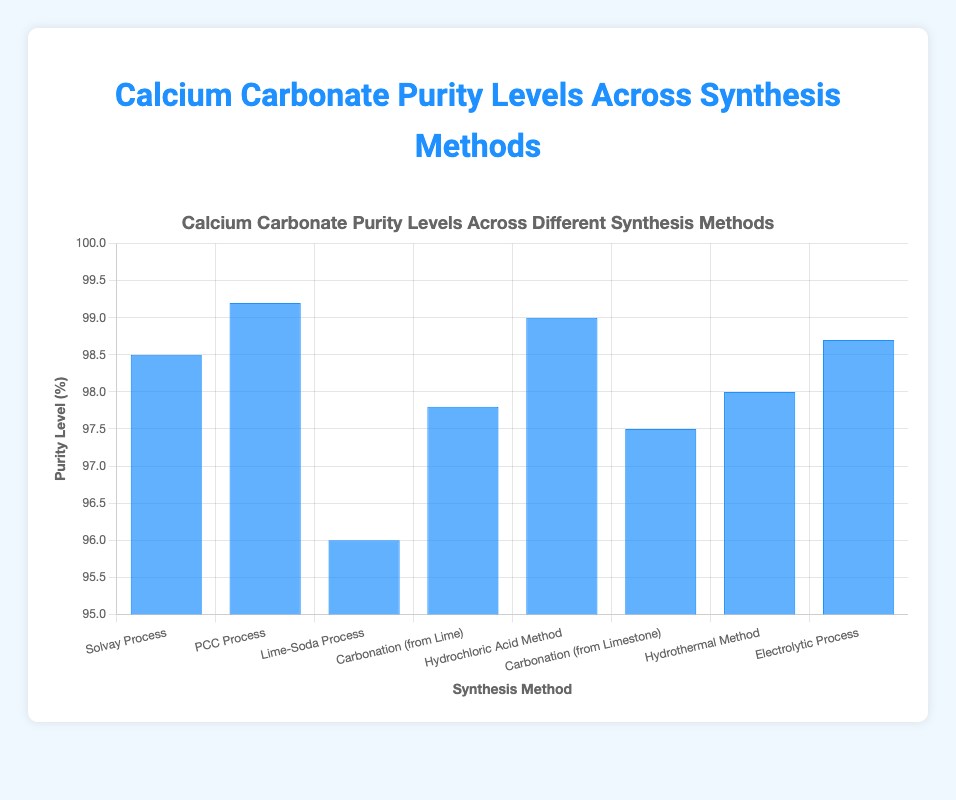What is the purity level of Calcium Carbonate produced by the Solvay Process? The chart shows the purity levels of Calcium Carbonate for various synthesis methods. Locate the bar for the Solvay Process and read the value from the y-axis.
Answer: 98.5% Which synthesis method yields the highest purity level of Calcium Carbonate? From the bar chart, compare the heights of all the bars. The PCC Process has the highest bar, indicating the highest purity level.
Answer: PCC Process Compare the purity levels between the Lime-Soda Process and the Hydrothermal Method. Which one is higher and by how much? Compare the heights of the bars for the Lime-Soda Process and the Hydrothermal Method. Subtract the purity level of the Lime-Soda Process from the Hydrothermal Method.
Answer: Hydrothermal Method by 2.0% What is the average purity level of Calcium Carbonate across all synthesis methods? Sum the purity levels of all synthesis methods and divide by the number of methods: (98.5 + 99.2 + 96.0 + 97.8 + 99.0 + 97.5 + 98.0 + 98.7) / 8.
Answer: 98.1% Which synthesis methods have a purity level of 98% or higher? Locate and list all the methods whose bars reach a value of 98% or higher on the y-axis.
Answer: Solvay Process, PCC Process, Hydrochloric Acid Method, Hydrothermal Method, Electrolytic Process What is the purity level difference between the highest and the lowest methods? Identify the highest and lowest purity levels, then subtract the smallest from the largest: 99.2 (PCC Process) - 96.0 (Lime-Soda Process).
Answer: 3.2% Are there any methods with the same purity level? If so, name them. Inspect the chart to see if any bars reach the same height. There are no identical heights in this chart.
Answer: No Which synthesis method shows a purity level just below 98%? Look for the bar that is just under the 98% mark on the y-axis.
Answer: Carbonation (from Lime) 